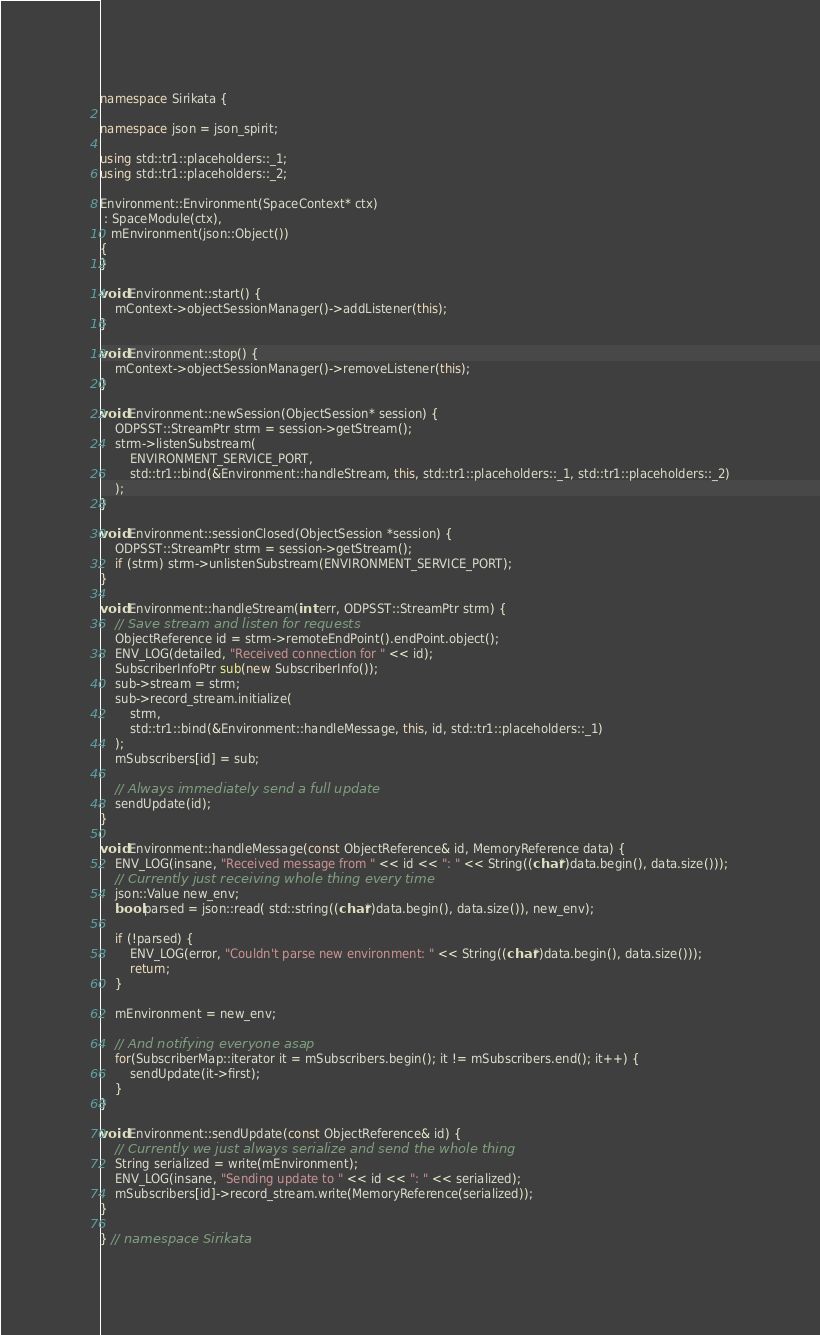<code> <loc_0><loc_0><loc_500><loc_500><_C++_>namespace Sirikata {

namespace json = json_spirit;

using std::tr1::placeholders::_1;
using std::tr1::placeholders::_2;

Environment::Environment(SpaceContext* ctx)
 : SpaceModule(ctx),
   mEnvironment(json::Object())
{
}

void Environment::start() {
    mContext->objectSessionManager()->addListener(this);
}

void Environment::stop() {
    mContext->objectSessionManager()->removeListener(this);
}

void Environment::newSession(ObjectSession* session) {
    ODPSST::StreamPtr strm = session->getStream();
    strm->listenSubstream(
        ENVIRONMENT_SERVICE_PORT,
        std::tr1::bind(&Environment::handleStream, this, std::tr1::placeholders::_1, std::tr1::placeholders::_2)
    );
}

void Environment::sessionClosed(ObjectSession *session) {
    ODPSST::StreamPtr strm = session->getStream();
    if (strm) strm->unlistenSubstream(ENVIRONMENT_SERVICE_PORT);
}

void Environment::handleStream(int err, ODPSST::StreamPtr strm) {
    // Save stream and listen for requests
    ObjectReference id = strm->remoteEndPoint().endPoint.object();
    ENV_LOG(detailed, "Received connection for " << id);
    SubscriberInfoPtr sub(new SubscriberInfo());
    sub->stream = strm;
    sub->record_stream.initialize(
        strm,
        std::tr1::bind(&Environment::handleMessage, this, id, std::tr1::placeholders::_1)
    );
    mSubscribers[id] = sub;

    // Always immediately send a full update
    sendUpdate(id);
}

void Environment::handleMessage(const ObjectReference& id, MemoryReference data) {
    ENV_LOG(insane, "Received message from " << id << ": " << String((char*)data.begin(), data.size()));
    // Currently just receiving whole thing every time
    json::Value new_env;
    bool parsed = json::read( std::string((char*)data.begin(), data.size()), new_env);

    if (!parsed) {
        ENV_LOG(error, "Couldn't parse new environment: " << String((char*)data.begin(), data.size()));
        return;
    }

    mEnvironment = new_env;

    // And notifying everyone asap
    for(SubscriberMap::iterator it = mSubscribers.begin(); it != mSubscribers.end(); it++) {
        sendUpdate(it->first);
    }
}

void Environment::sendUpdate(const ObjectReference& id) {
    // Currently we just always serialize and send the whole thing
    String serialized = write(mEnvironment);
    ENV_LOG(insane, "Sending update to " << id << ": " << serialized);
    mSubscribers[id]->record_stream.write(MemoryReference(serialized));
}

} // namespace Sirikata
</code> 